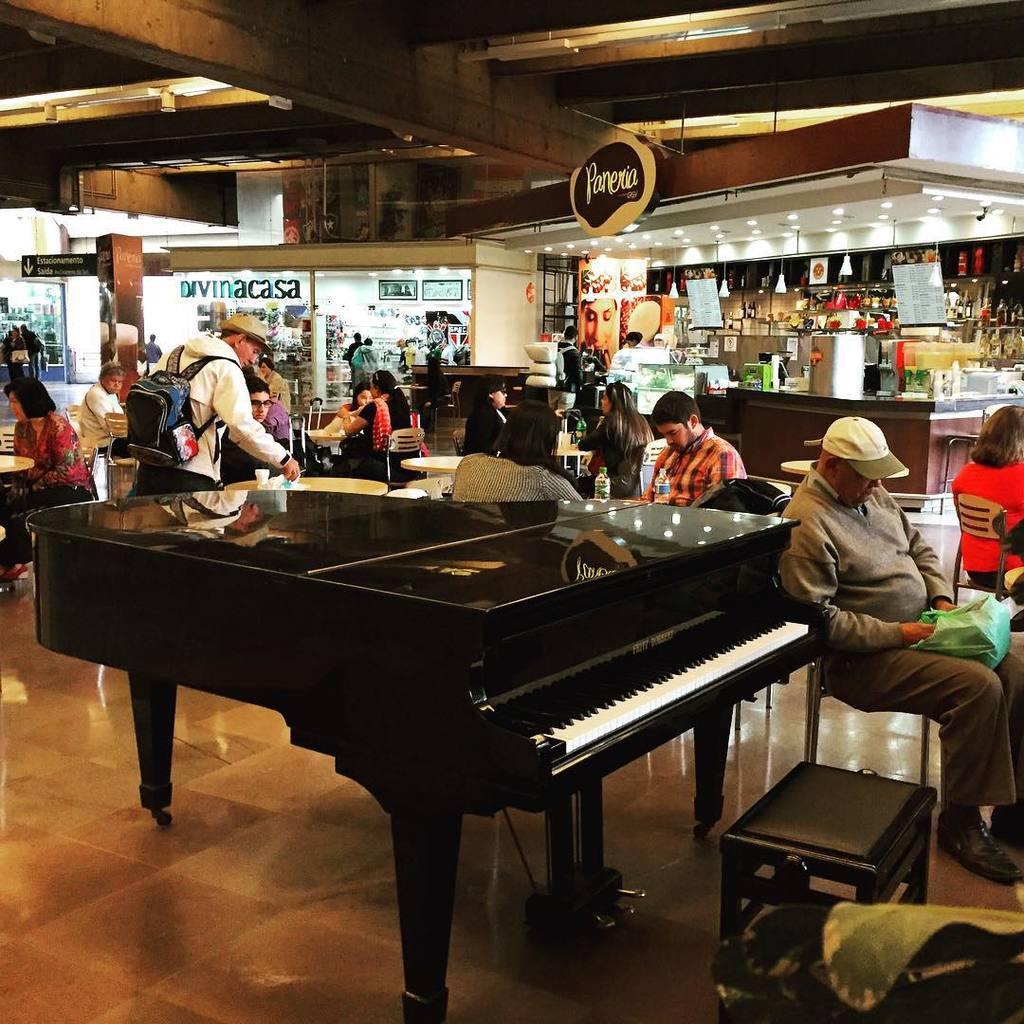In one or two sentences, can you explain what this image depicts? In this image I can see few people are sitting on the chairs. In the background I can see some stalls. In the middle of the image there is a piano. On the right bottom of the side there is a small stool. 